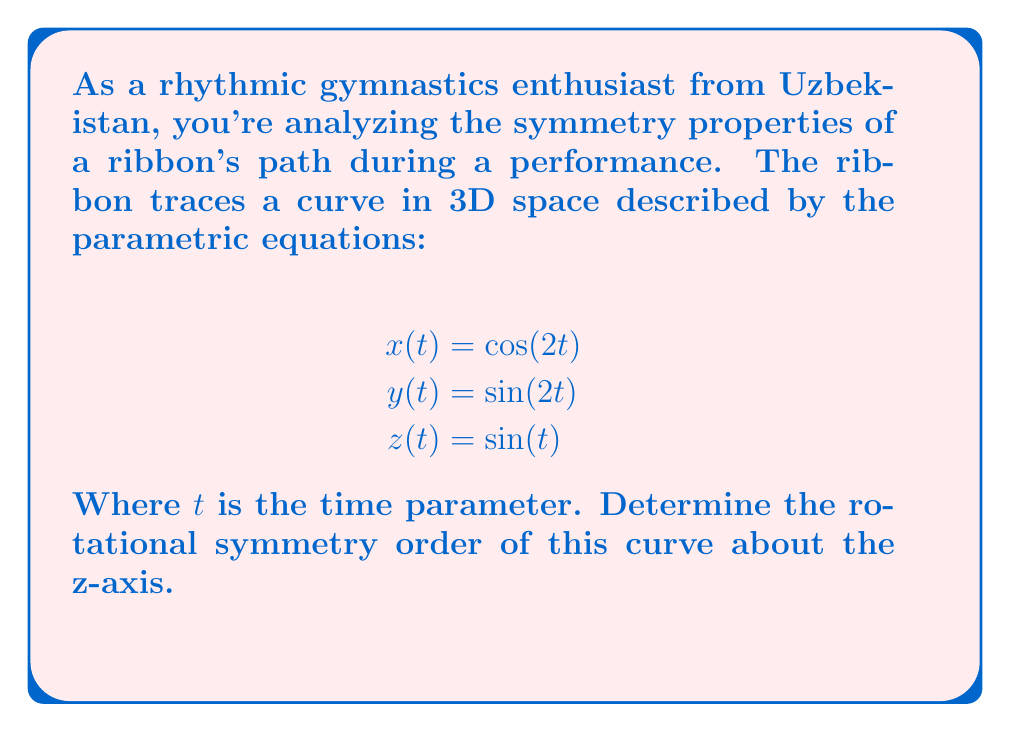Help me with this question. To determine the rotational symmetry order about the z-axis, we need to follow these steps:

1) First, observe that the x and y components form a circle in the xy-plane:
   $$x^2 + y^2 = \cos^2(2t) + \sin^2(2t) = 1$$

2) The period of this circular motion is:
   $$T_{xy} = \frac{2\pi}{2} = \pi$$

3) For the z-component, its period is:
   $$T_z = 2\pi$$

4) The curve will repeat itself when both the xy-motion and z-motion complete full cycles. This occurs at the least common multiple (LCM) of their periods:
   $$T_{total} = LCM(\pi, 2\pi) = 2\pi$$

5) During this total period, the xy-plane component makes two full rotations (because $2\pi / \pi = 2$).

6) Therefore, the curve has 2-fold rotational symmetry about the z-axis. It looks the same after a 180° rotation ($\pi$ radians).

This can be verified algebraically:
$$x(t+\pi) = \cos(2t+2\pi) = \cos(2t) = x(t)$$
$$y(t+\pi) = \sin(2t+2\pi) = \sin(2t) = y(t)$$
$$z(t+\pi) = \sin(t+\pi) = -\sin(t) = -z(t)$$

The negative sign in z doesn't affect rotational symmetry about the z-axis.
Answer: 2 